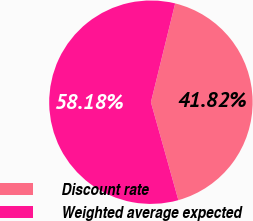<chart> <loc_0><loc_0><loc_500><loc_500><pie_chart><fcel>Discount rate<fcel>Weighted average expected<nl><fcel>41.82%<fcel>58.18%<nl></chart> 